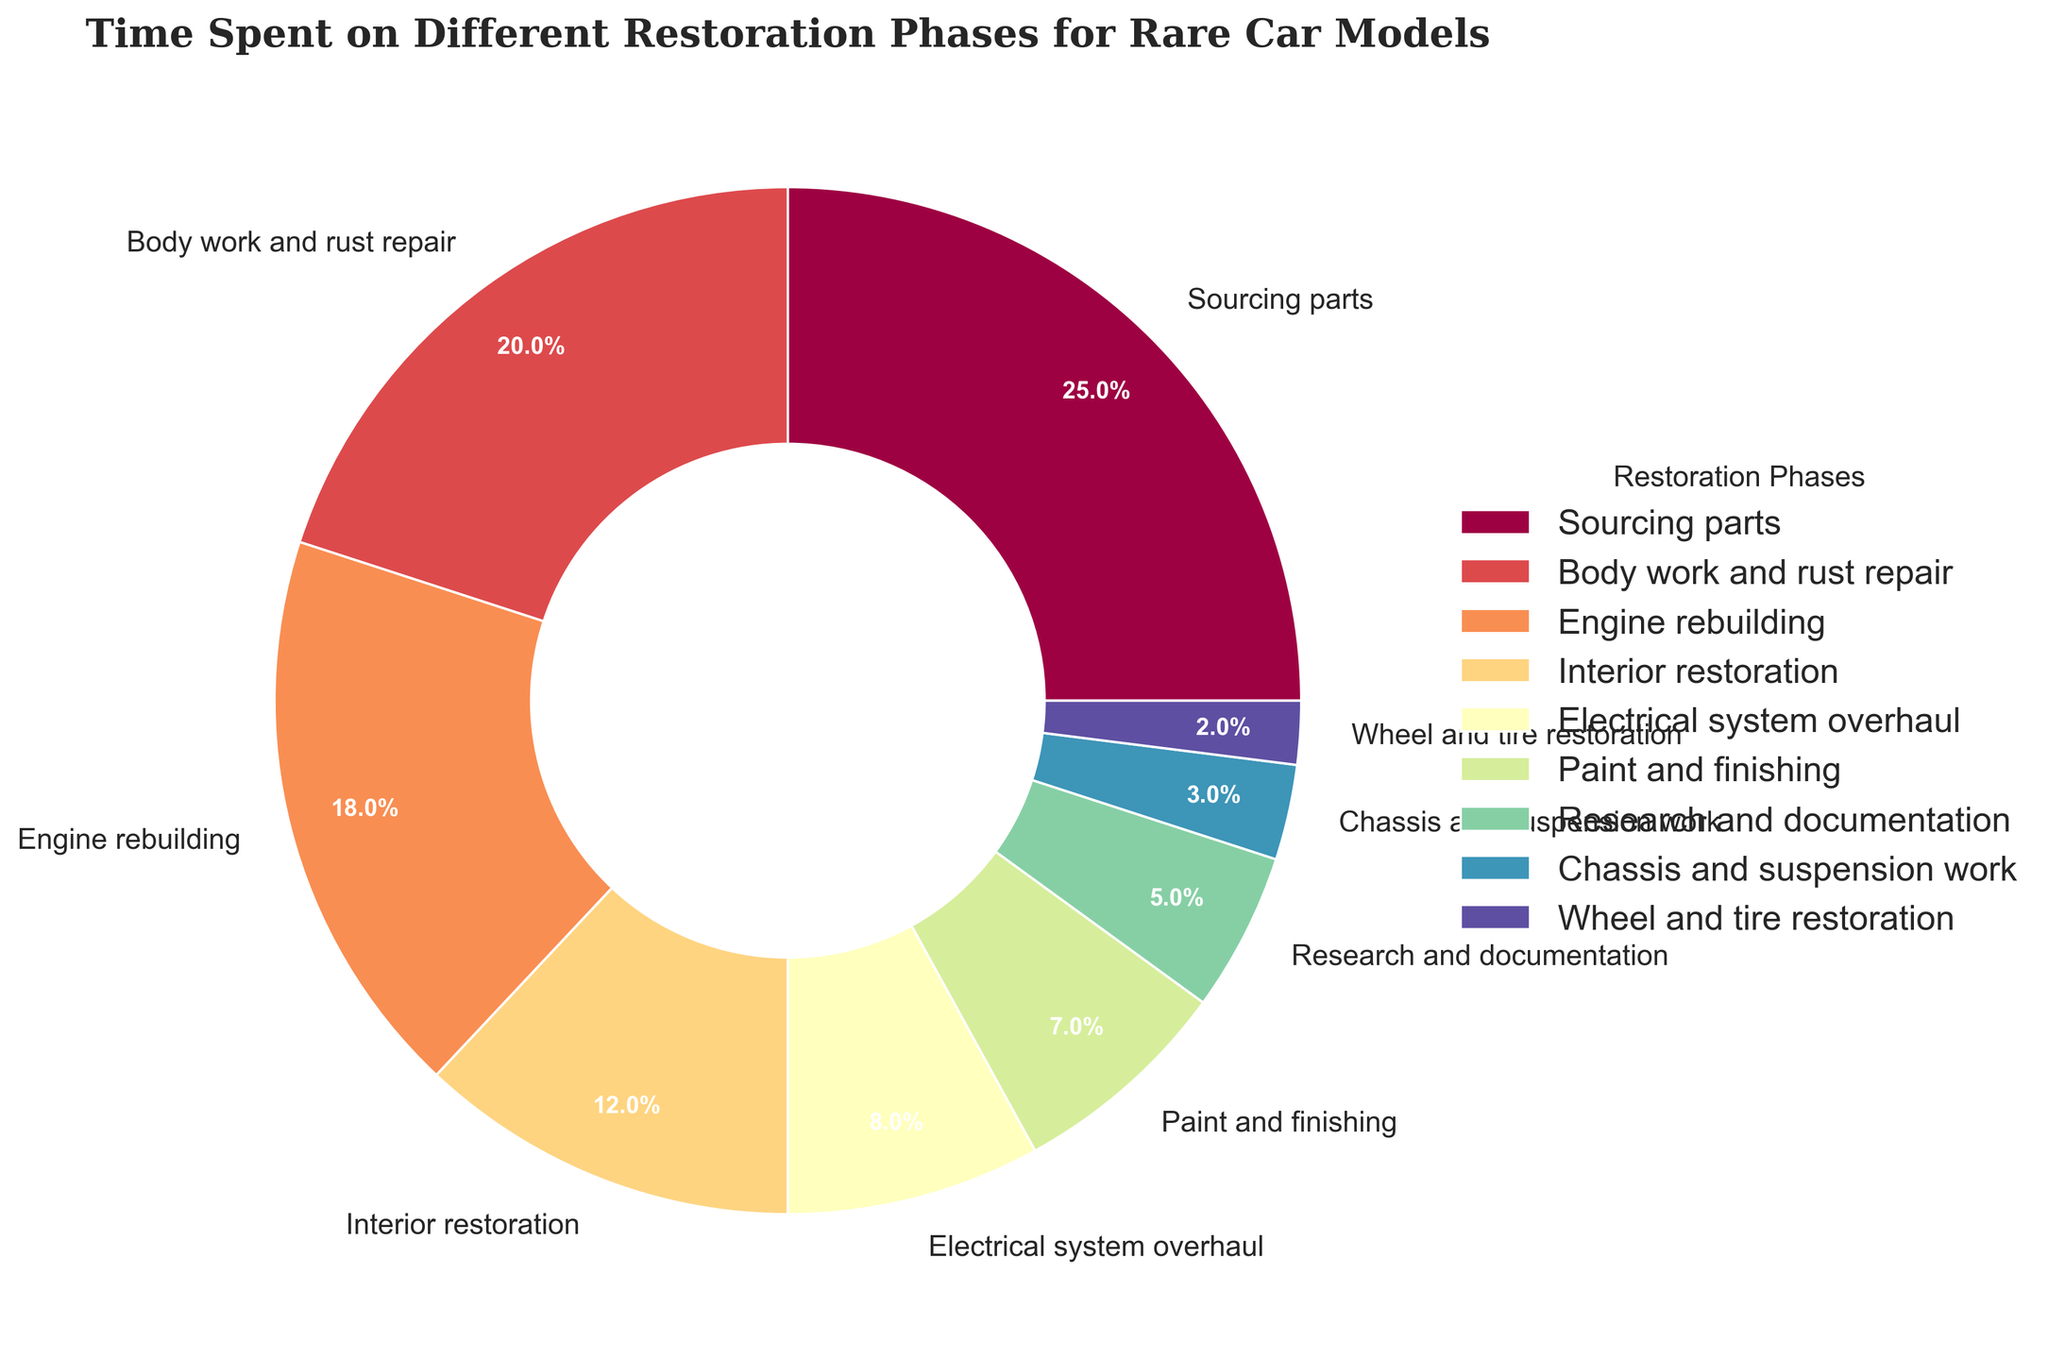Which restoration phase takes up the most time? The pie chart shows the percentage of time spent on each restoration phase. The largest segment in the chart represents 'Sourcing parts', which has the highest percentage.
Answer: Sourcing parts What percentage of time is spent on sourcing parts and body work and rust repair combined? The percentages for 'Sourcing parts' and 'Body work and rust repair' are 25% and 20% respectively. Adding these gives 25% + 20% = 45%.
Answer: 45% Which phase takes less time, engine rebuilding or interior restoration? Looking at the pie chart, the percentage for 'Engine rebuilding' is 18% and for 'Interior restoration' is 12%. Since 12% is less than 18%, 'Interior restoration' takes less time.
Answer: Interior restoration What is the difference in time percentage between paint and finishing and chassis and suspension work? The percentage for 'Paint and finishing' is 7% and for 'Chassis and suspension work' is 3%. The difference is 7% - 3% = 4%.
Answer: 4% Are more time spent on electrical system overhaul or wheel and tire restoration? The pie chart indicates that 'Electrical system overhaul' takes up 8% and 'Wheel and tire restoration' takes up 2%. Since 8% is greater than 2%, more time is spent on 'Electrical system overhaul'.
Answer: Electrical system overhaul How much time is spent on both interior restoration and research and documentation together? The percentage for 'Interior restoration' is 12% and for 'Research and documentation' is 5%. Adding these gives 12% + 5% = 17%.
Answer: 17% Which phase uses the least time and by what percentage? According to the pie chart, 'Wheel and tire restoration' uses the least time at 2%.
Answer: Wheel and tire restoration, 2% Are the time spent on engine rebuilding and electrical system overhaul together more or less than sourcing parts? The percentages for 'Engine rebuilding' and 'Electrical system overhaul' are 18% and 8% respectively. Together, they add up to 18% + 8% = 26%. 'Sourcing parts' is 25%, so 26% is more than 25%.
Answer: More What is the mean percentage of the phases not including sourcing parts? Add percentages: 20% + 18% + 12% + 8% + 7% + 5% + 3% + 2% = 75%. There are 8 phases excluding sourcing parts, so the mean is 75% / 8 ≈ 9.4%.
Answer: 9.4% By how much does the phase with the second most time differ from the time spent on paint and finishing? The phase with the second most time is 'Body work and rust repair' at 20% and 'Paint and finishing' is 7%. The difference is 20% - 7% = 13%.
Answer: 13% 